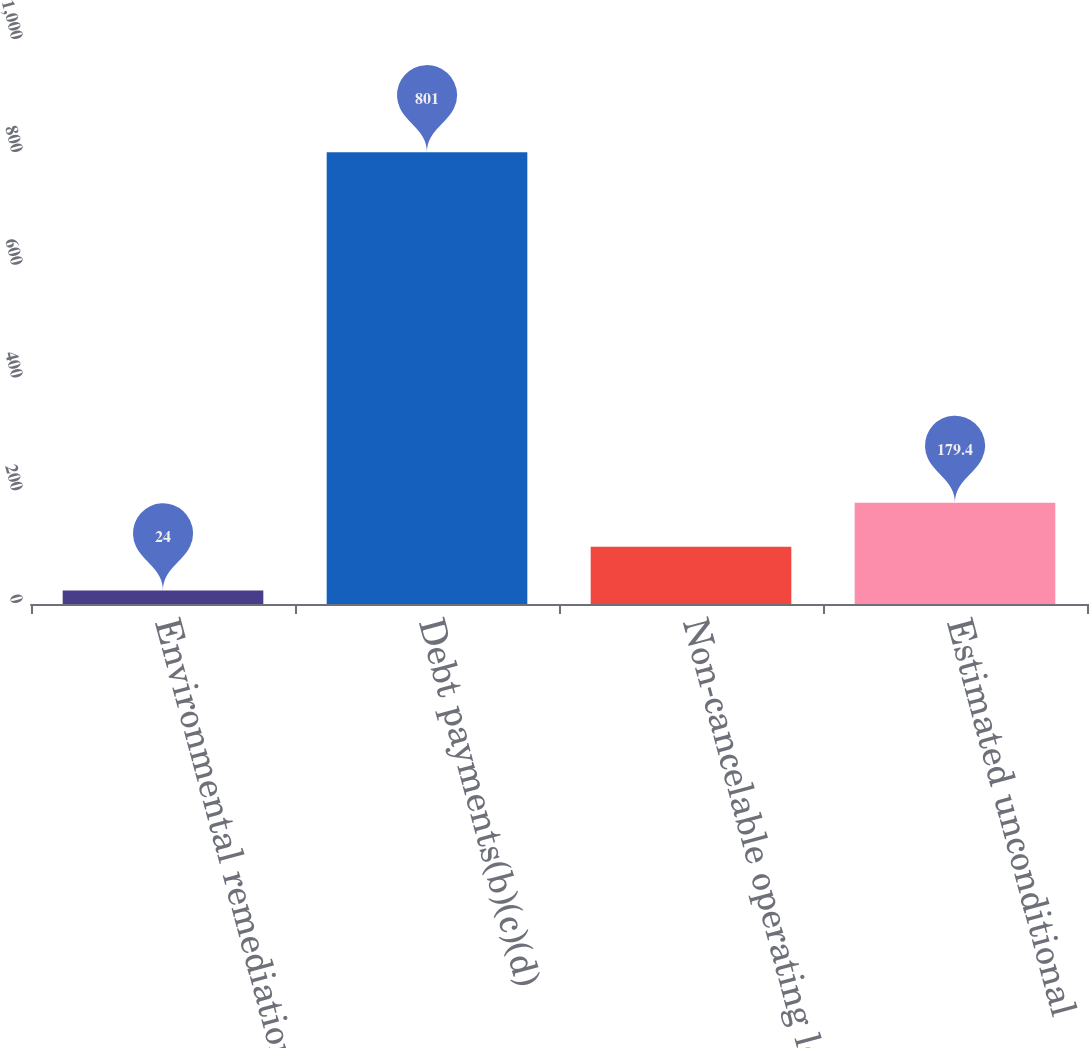<chart> <loc_0><loc_0><loc_500><loc_500><bar_chart><fcel>Environmental remediation<fcel>Debt payments(b)(c)(d)<fcel>Non-cancelable operating lease<fcel>Estimated unconditional<nl><fcel>24<fcel>801<fcel>101.7<fcel>179.4<nl></chart> 